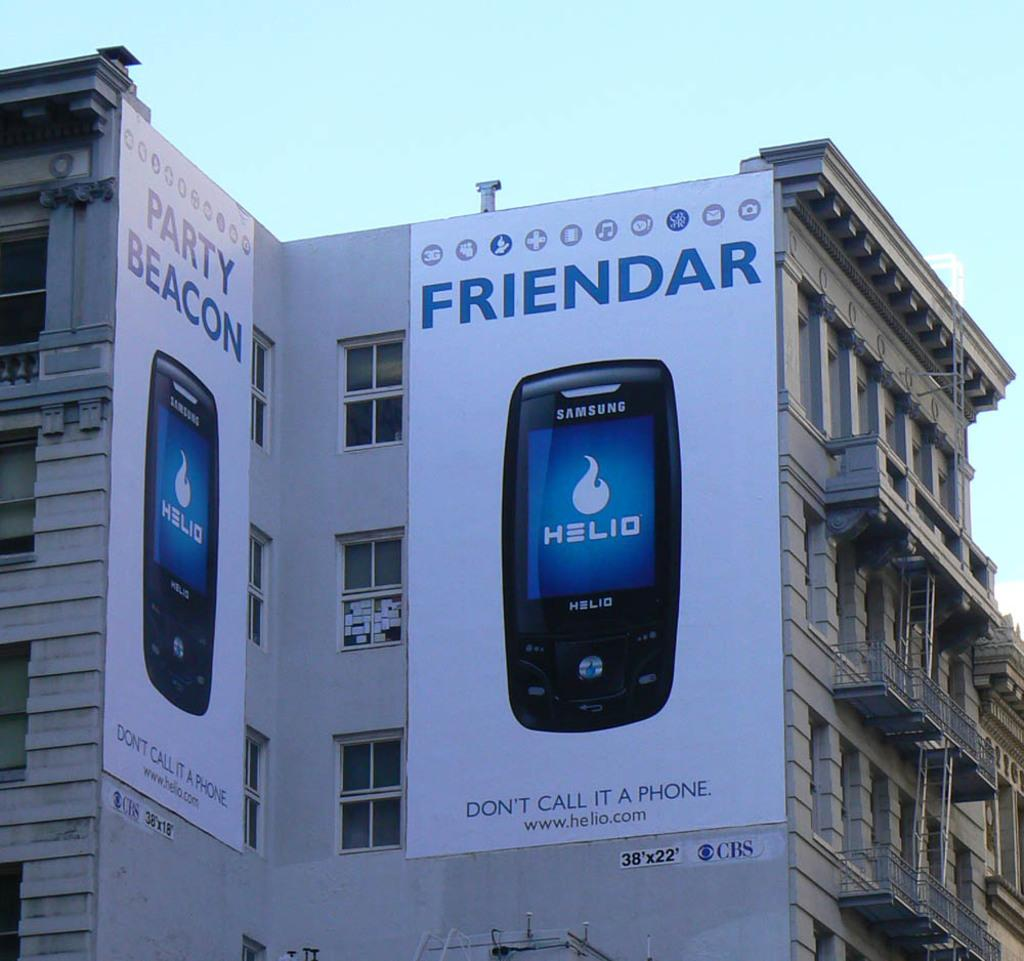<image>
Share a concise interpretation of the image provided. Large building with a banner that says "FRIENDAR" and shows a phone. 